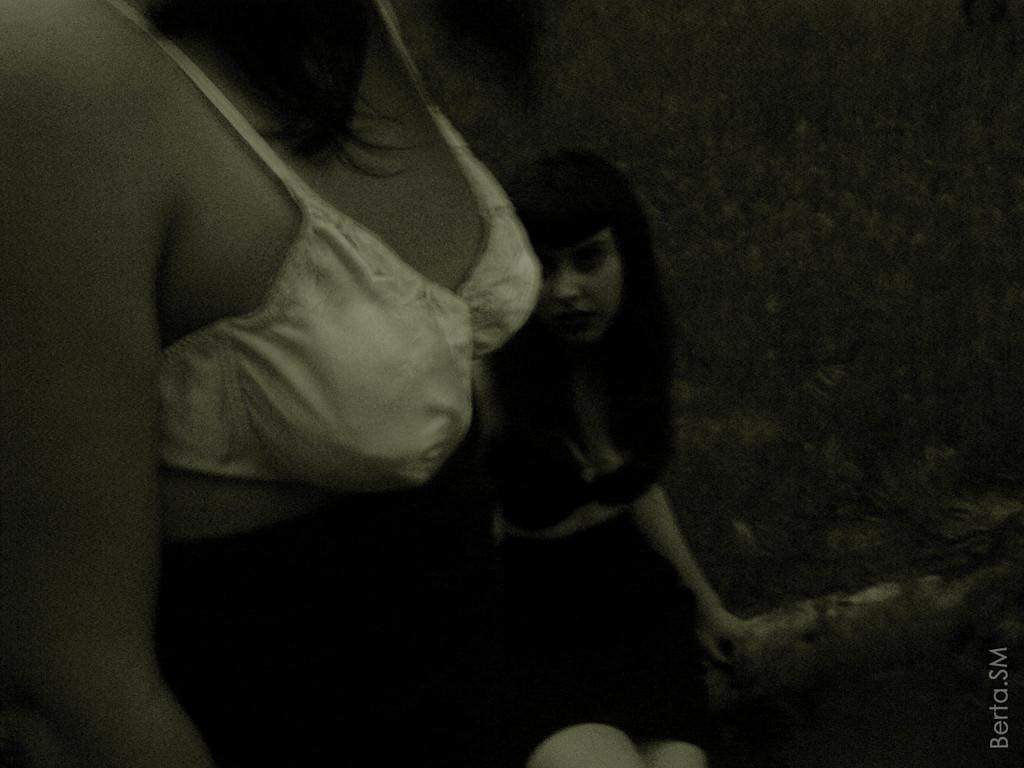What is the color scheme of the image? The image is black and white. How many people are in the image? There are two persons in the image. What can be observed about the background of the image? The background of the image is dark. Is there any additional marking or feature on the image? Yes, there is a watermark on the image. Can you see any ants crawling on the persons in the image? There are no ants visible in the image. What type of vessel is being used by the persons in the image? The image is in black and white, and there is no vessel present in the image. Are there any leaves visible in the image? There are no leaves visible in the image. 